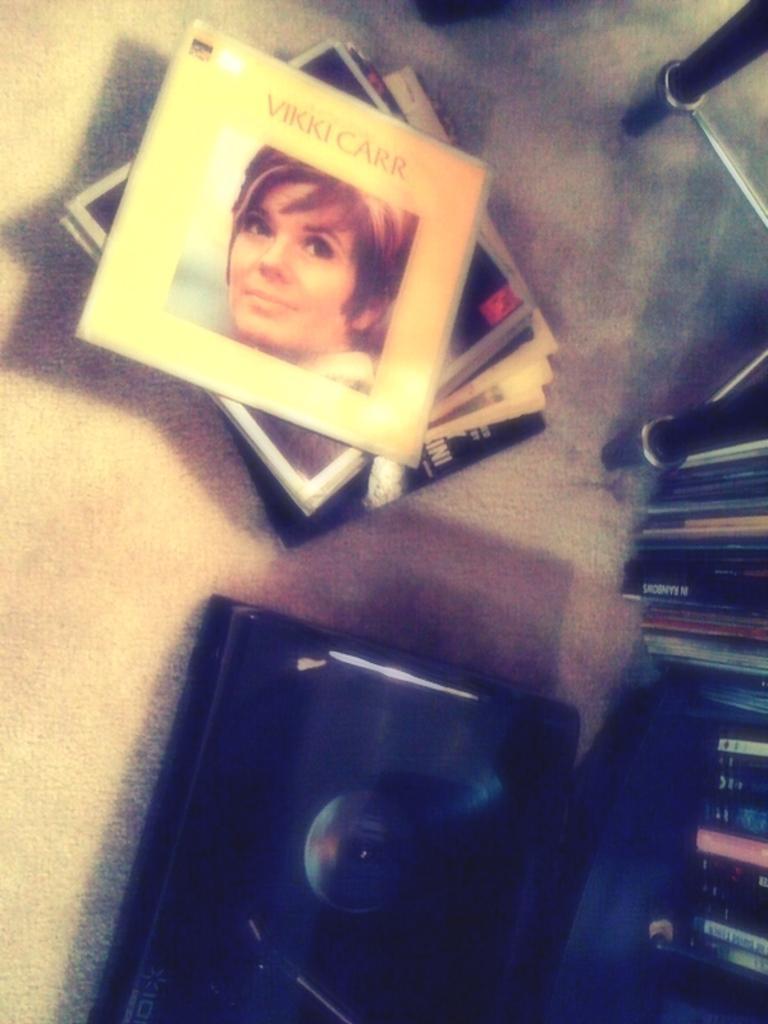How would you summarize this image in a sentence or two? In this image I see a photo of a woman on this thing and I see something is written and I see number of things on the floor and I see the black color thing over here. 